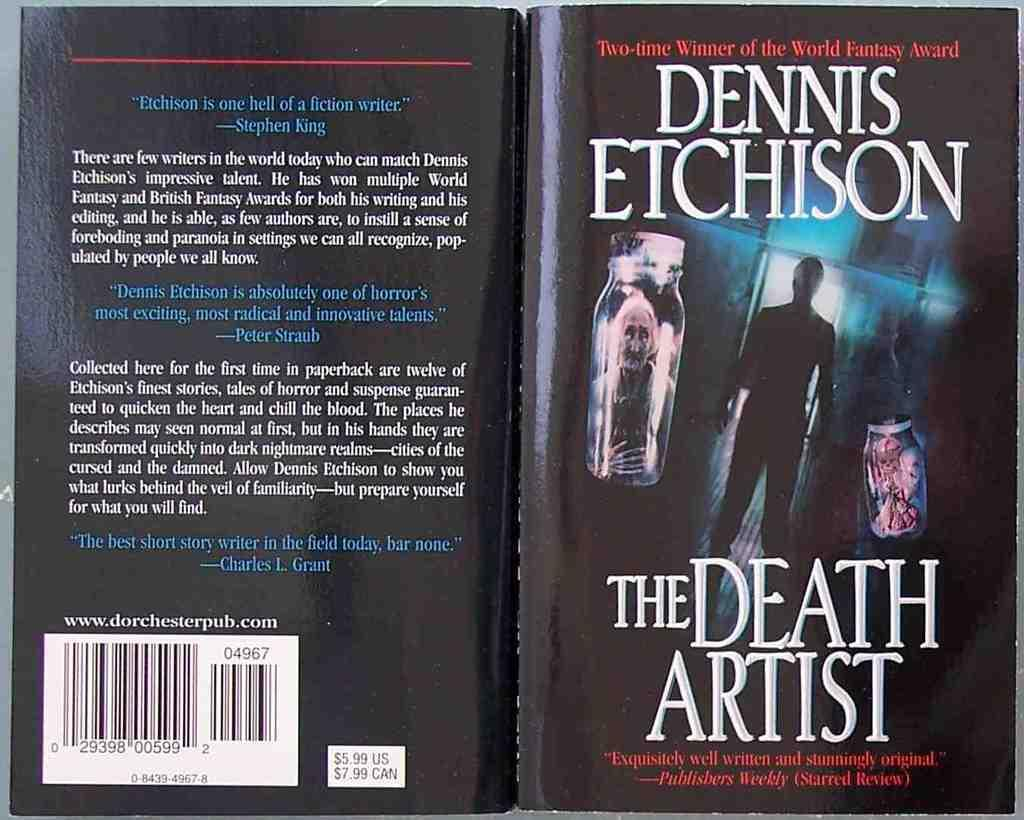<image>
Relay a brief, clear account of the picture shown. A paperback book titled The Death Artist by Dennis Etchison. 